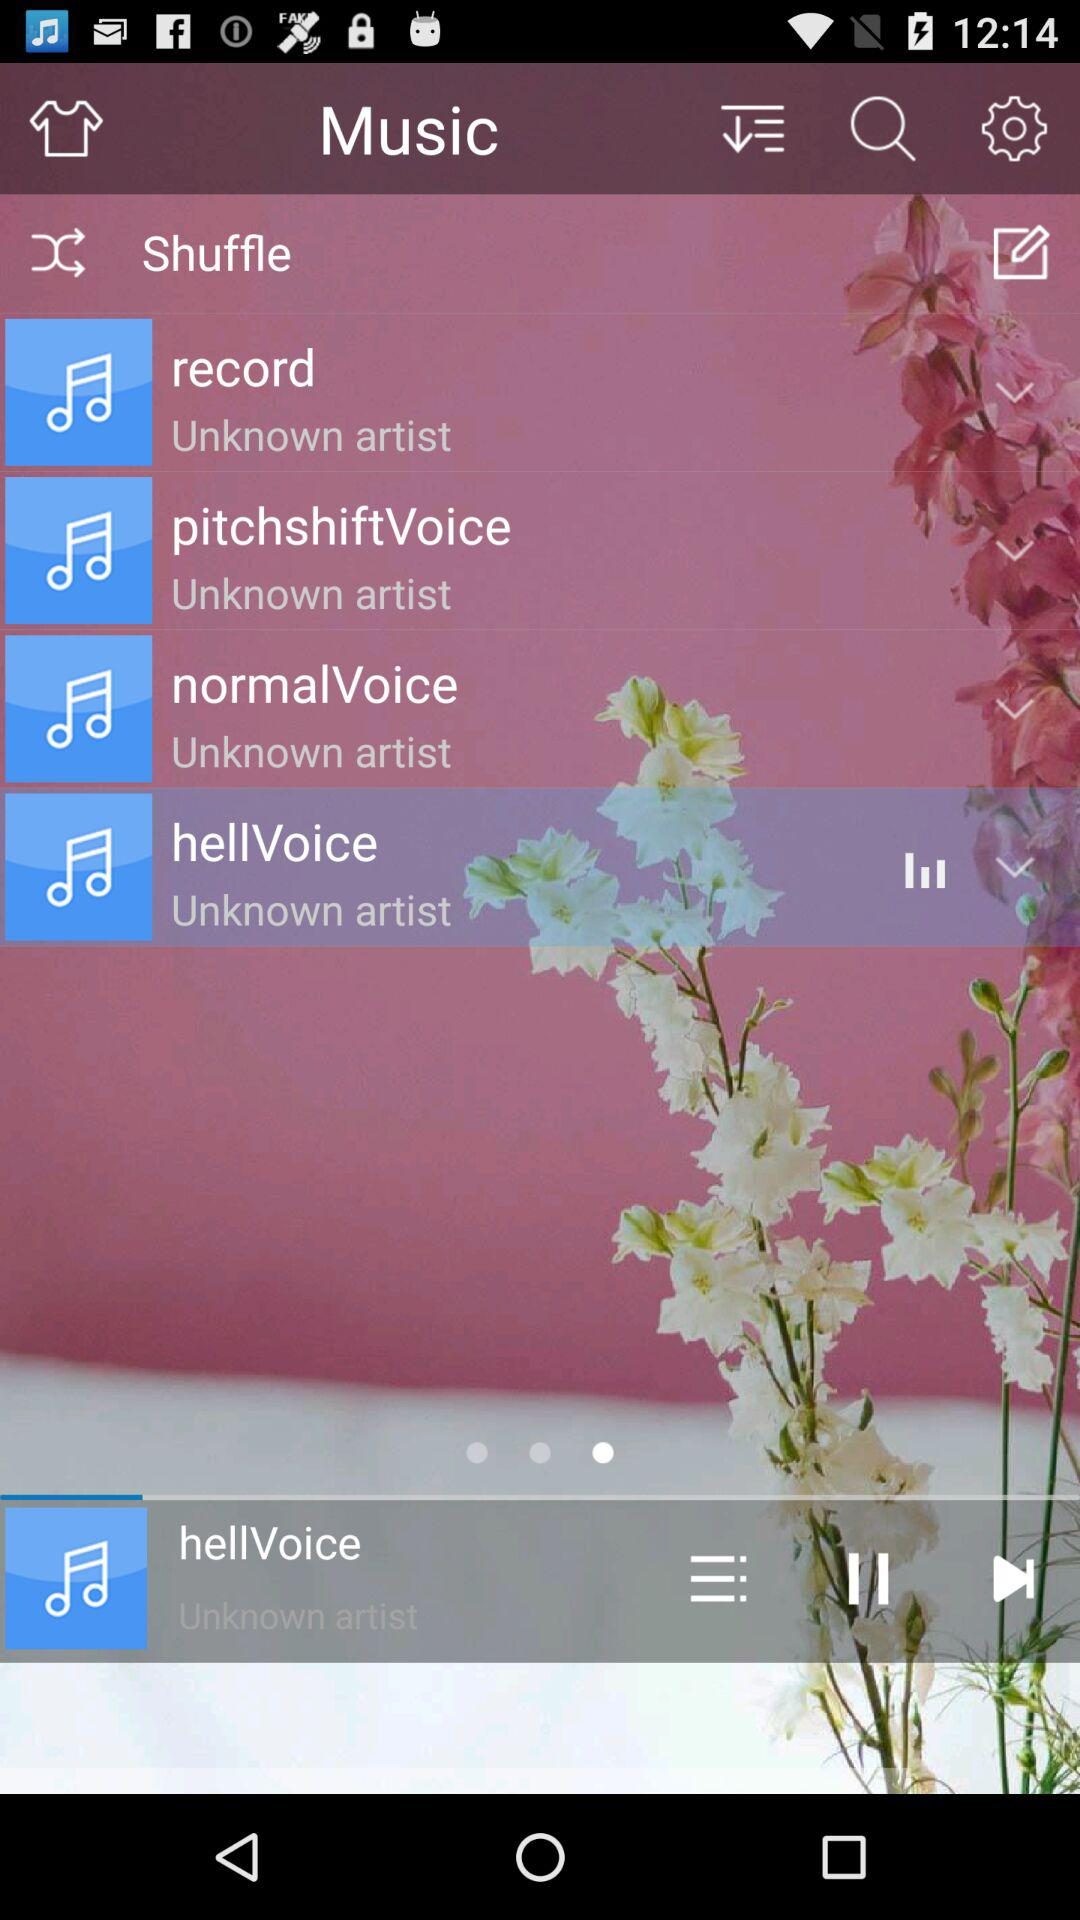What is the application name? The application name is "Music". 